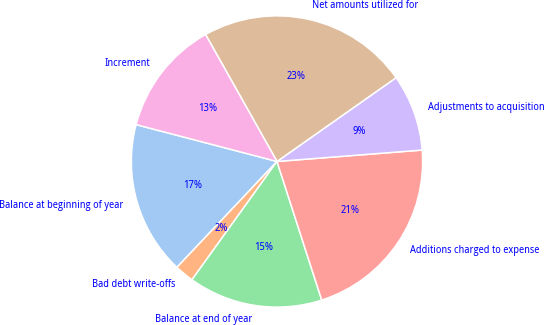<chart> <loc_0><loc_0><loc_500><loc_500><pie_chart><fcel>Balance at beginning of year<fcel>Bad debt write-offs<fcel>Balance at end of year<fcel>Additions charged to expense<fcel>Adjustments to acquisition<fcel>Net amounts utilized for<fcel>Increment<nl><fcel>17.02%<fcel>2.13%<fcel>14.89%<fcel>21.28%<fcel>8.51%<fcel>23.4%<fcel>12.77%<nl></chart> 